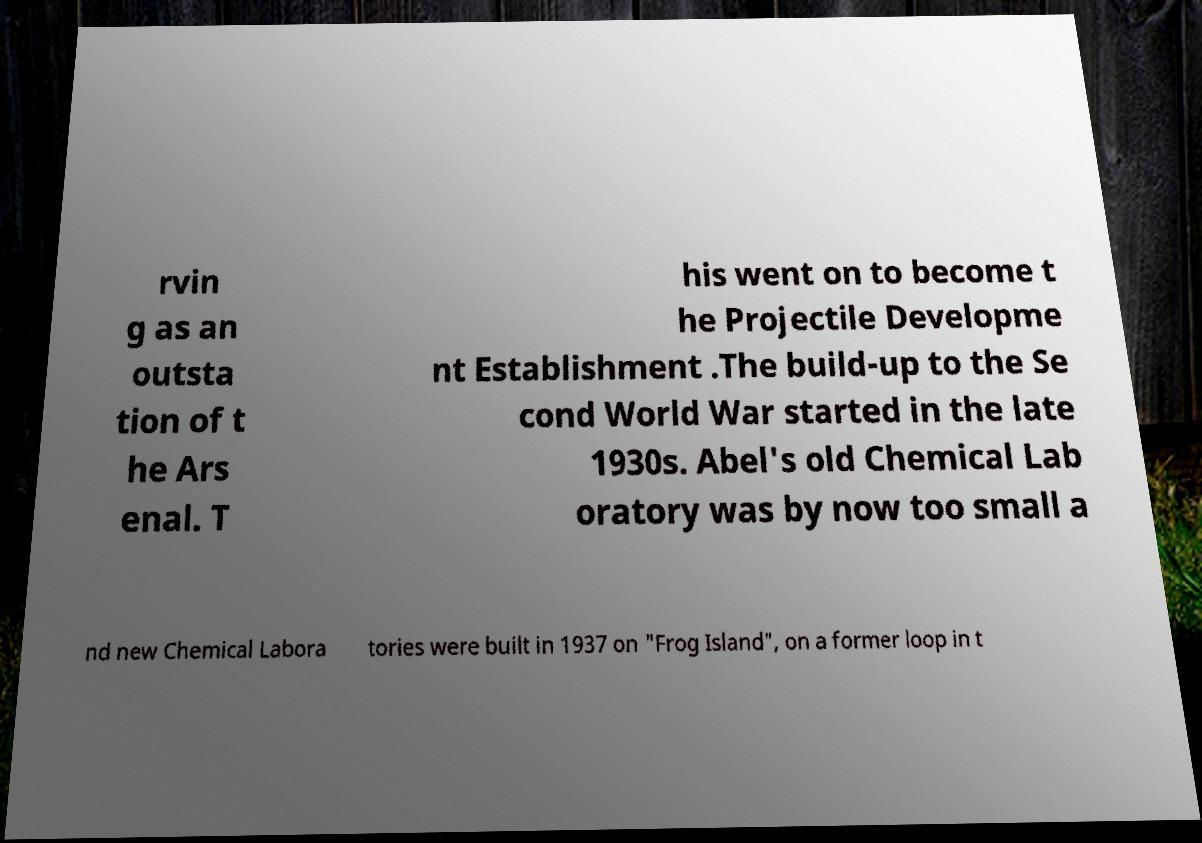Can you accurately transcribe the text from the provided image for me? rvin g as an outsta tion of t he Ars enal. T his went on to become t he Projectile Developme nt Establishment .The build-up to the Se cond World War started in the late 1930s. Abel's old Chemical Lab oratory was by now too small a nd new Chemical Labora tories were built in 1937 on "Frog Island", on a former loop in t 